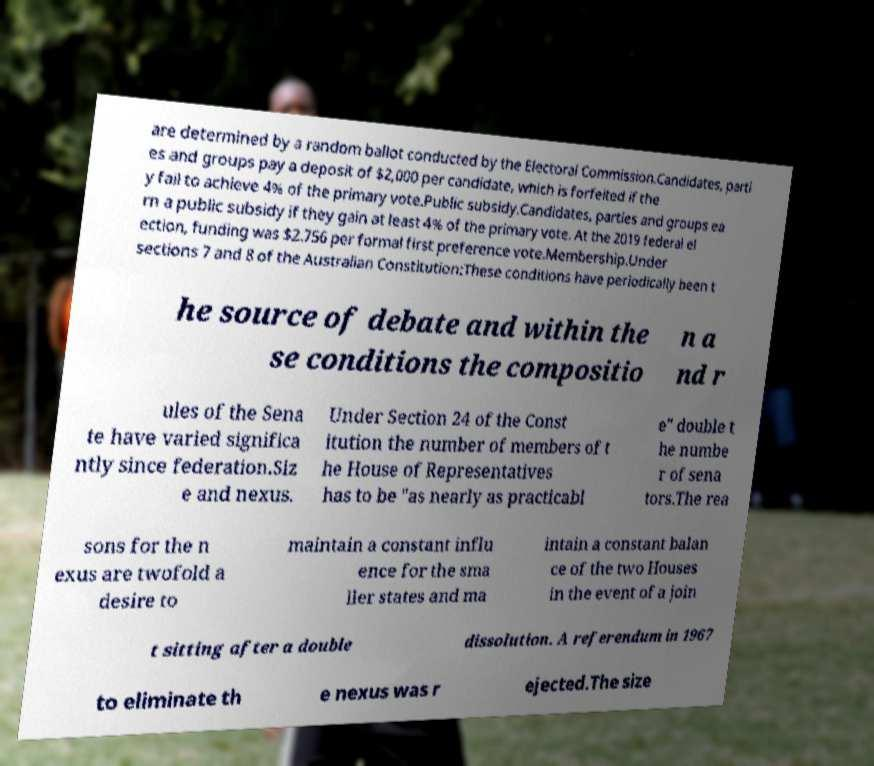There's text embedded in this image that I need extracted. Can you transcribe it verbatim? are determined by a random ballot conducted by the Electoral Commission.Candidates, parti es and groups pay a deposit of $2,000 per candidate, which is forfeited if the y fail to achieve 4% of the primary vote.Public subsidy.Candidates, parties and groups ea rn a public subsidy if they gain at least 4% of the primary vote. At the 2019 federal el ection, funding was $2.756 per formal first preference vote.Membership.Under sections 7 and 8 of the Australian Constitution:These conditions have periodically been t he source of debate and within the se conditions the compositio n a nd r ules of the Sena te have varied significa ntly since federation.Siz e and nexus. Under Section 24 of the Const itution the number of members of t he House of Representatives has to be "as nearly as practicabl e" double t he numbe r of sena tors.The rea sons for the n exus are twofold a desire to maintain a constant influ ence for the sma ller states and ma intain a constant balan ce of the two Houses in the event of a join t sitting after a double dissolution. A referendum in 1967 to eliminate th e nexus was r ejected.The size 